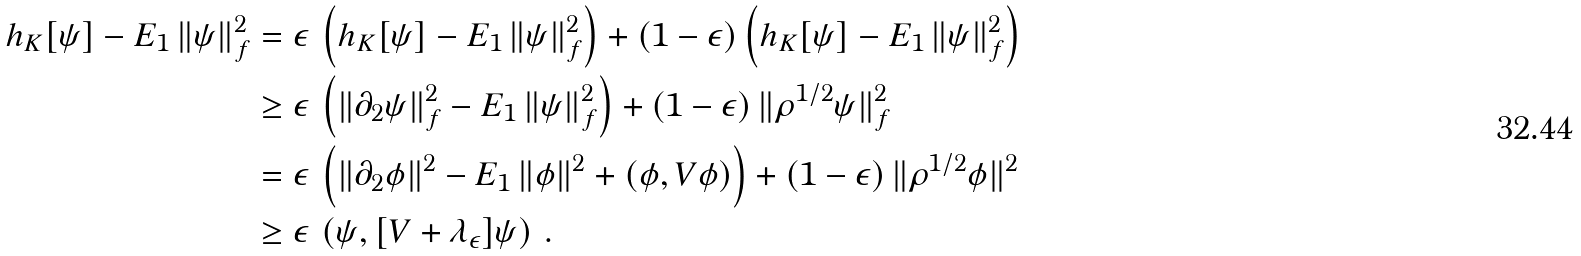Convert formula to latex. <formula><loc_0><loc_0><loc_500><loc_500>h _ { K } [ \psi ] - E _ { 1 } \, \| \psi \| _ { f } ^ { 2 } & = \epsilon \, \left ( h _ { K } [ \psi ] - E _ { 1 } \, \| \psi \| _ { f } ^ { 2 } \right ) + ( 1 - \epsilon ) \left ( h _ { K } [ \psi ] - E _ { 1 } \, \| \psi \| _ { f } ^ { 2 } \right ) \\ & \geq \epsilon \, \left ( \| \partial _ { 2 } \psi \| _ { f } ^ { 2 } - E _ { 1 } \, \| \psi \| _ { f } ^ { 2 } \right ) + ( 1 - \epsilon ) \, \| \rho ^ { 1 / 2 } \psi \| _ { f } ^ { 2 } \\ & = \epsilon \, \left ( \| \partial _ { 2 } \phi \| ^ { 2 } - E _ { 1 } \, \| \phi \| ^ { 2 } + ( \phi , V \phi ) \right ) + ( 1 - \epsilon ) \, \| \rho ^ { 1 / 2 } \phi \| ^ { 2 } \\ & \geq \epsilon \, \left ( \psi , [ V + \lambda _ { \epsilon } ] \psi \right ) \, .</formula> 